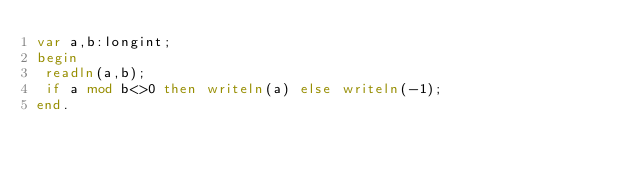Convert code to text. <code><loc_0><loc_0><loc_500><loc_500><_Pascal_>var a,b:longint;
begin
 readln(a,b);
 if a mod b<>0 then writeln(a) else writeln(-1);
end.</code> 